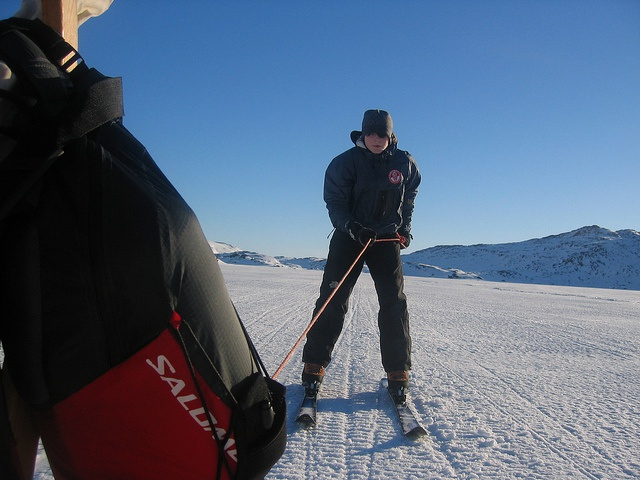Describe the objects in this image and their specific colors. I can see backpack in blue, black, maroon, and gray tones, people in blue, black, gray, darkgray, and navy tones, skis in blue, gray, black, darkgray, and darkblue tones, and skis in blue, black, gray, and navy tones in this image. 